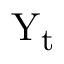Convert formula to latex. <formula><loc_0><loc_0><loc_500><loc_500>Y _ { t }</formula> 